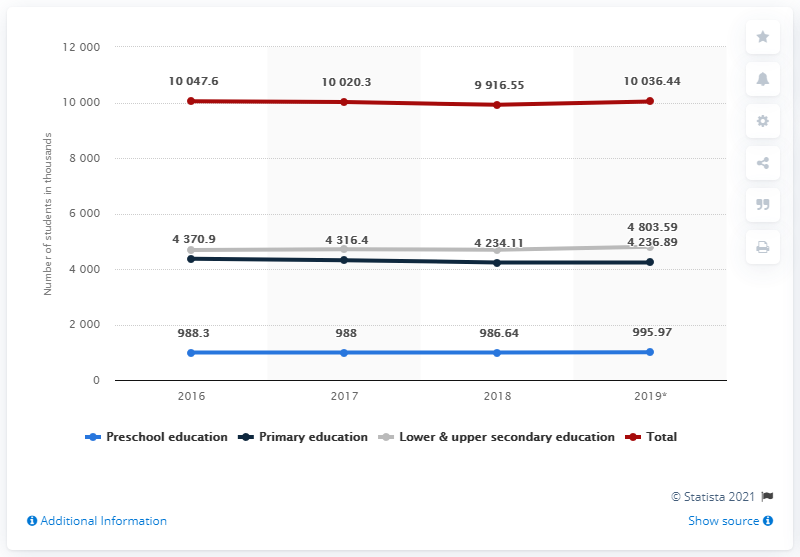Indicate a few pertinent items in this graphic. The value of the red line in 2016 was 10047.6. The average of the blue line data is approximately 989.73. 